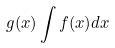<formula> <loc_0><loc_0><loc_500><loc_500>g ( x ) \int f ( x ) d x</formula> 